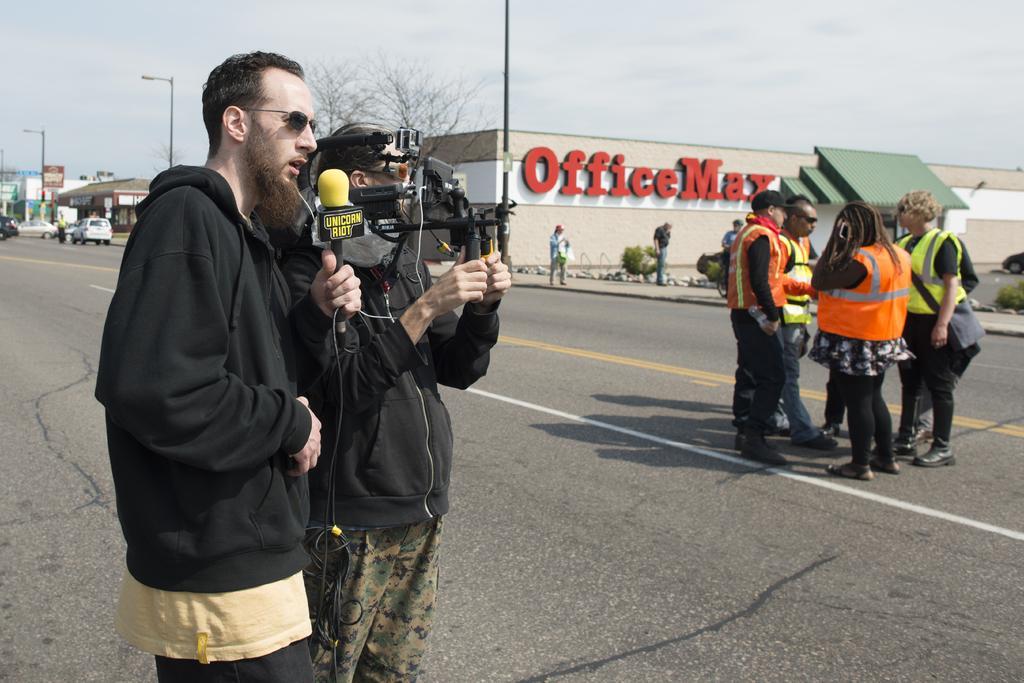Can you describe this image briefly? In this image we can see some people standing on the road and on the left we can see persons are holding the camera and a mike. In the background we can see some buildings, trees and also poles. At the top there is a cloudy sky. 